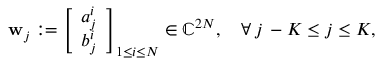Convert formula to latex. <formula><loc_0><loc_0><loc_500><loc_500>\begin{array} { r } { w _ { j } \colon = \left [ \begin{array} { l } { a _ { j } ^ { i } } \\ { b _ { j } ^ { i } } \end{array} \right ] _ { 1 \leq i \leq N } \in \mathbb { C } ^ { 2 N } , \quad \forall \, j \, - K \leq j \leq K , } \end{array}</formula> 